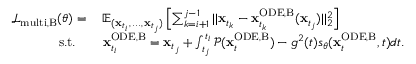<formula> <loc_0><loc_0><loc_500><loc_500>\begin{array} { r l } { \mathcal { L } _ { m u l t i , B } ( \theta ) = \, } & { \mathbb { E } _ { ( x _ { t _ { i } } , \, \dots , \, x _ { t _ { j } } ) } \left [ \sum _ { k = i + 1 } ^ { j - 1 } | | x _ { t _ { k } } - x _ { t _ { k } } ^ { O D E , B } ( x _ { t _ { j } } ) | | _ { 2 } ^ { 2 } \right ] } \\ { s . t . \quad } & { x _ { t _ { i } } ^ { O D E , B } = x _ { t _ { j } } + \int _ { t _ { j } } ^ { t _ { i } } \mathcal { P } ( x _ { t } ^ { O D E , B } ) - g ^ { 2 } ( t ) s _ { \theta } ( x _ { t } ^ { O D E , B } , t ) d t . } \end{array}</formula> 